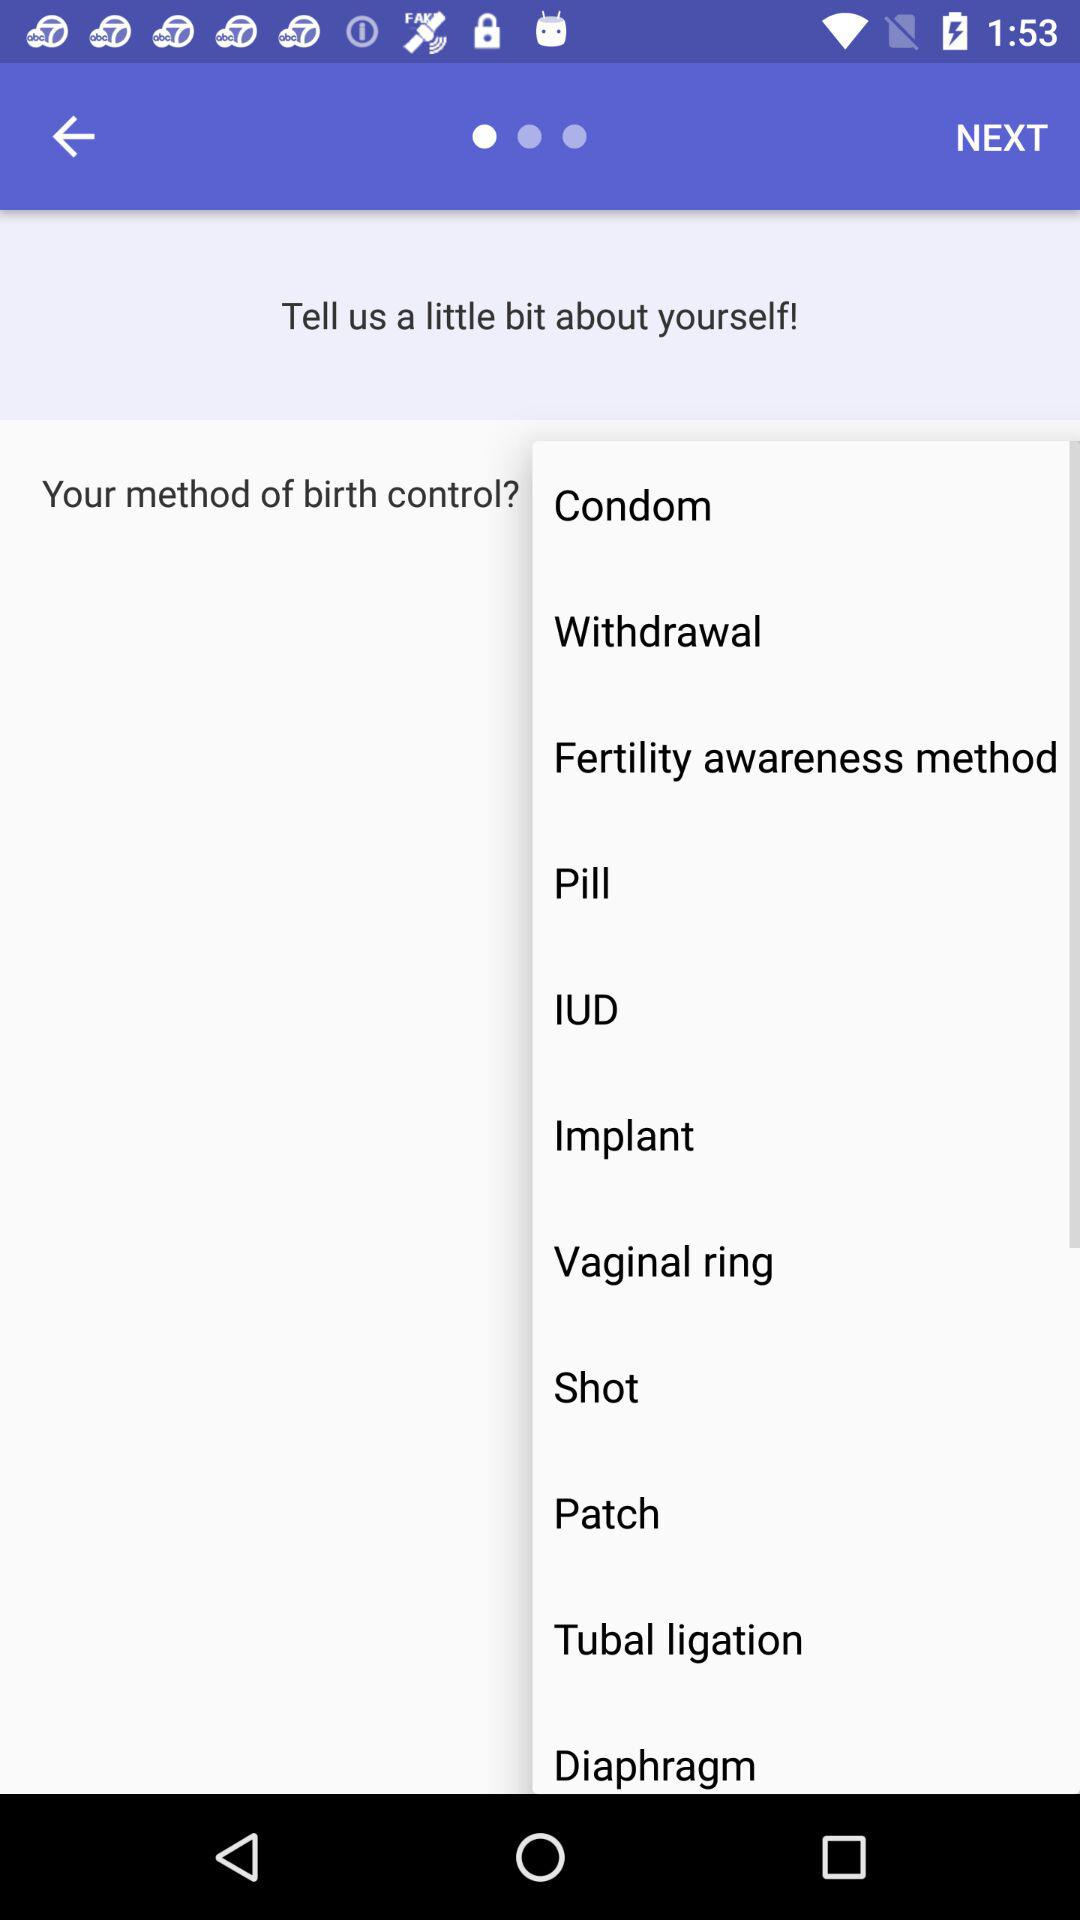What are the birth control methods that I can select? The birth control methods are "Condom", "Withdrawal", "Fertility awareness method", "Pill", "IUD", "Implant", "Vaginal ring", "Shot", "Patch", "Tubal ligation" and "Diaphragm". 